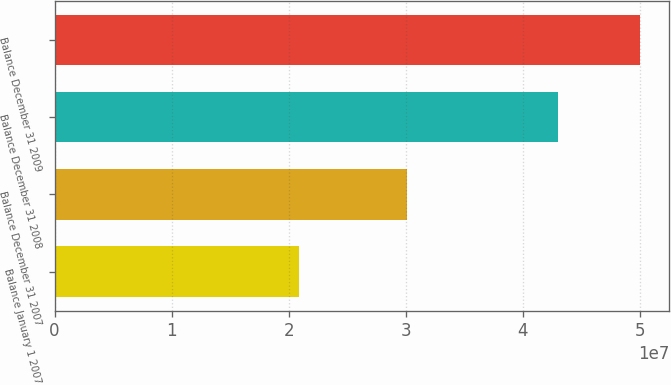<chart> <loc_0><loc_0><loc_500><loc_500><bar_chart><fcel>Balance January 1 2007<fcel>Balance December 31 2007<fcel>Balance December 31 2008<fcel>Balance December 31 2009<nl><fcel>2.08457e+07<fcel>3.00741e+07<fcel>4.29856e+07<fcel>5.00059e+07<nl></chart> 